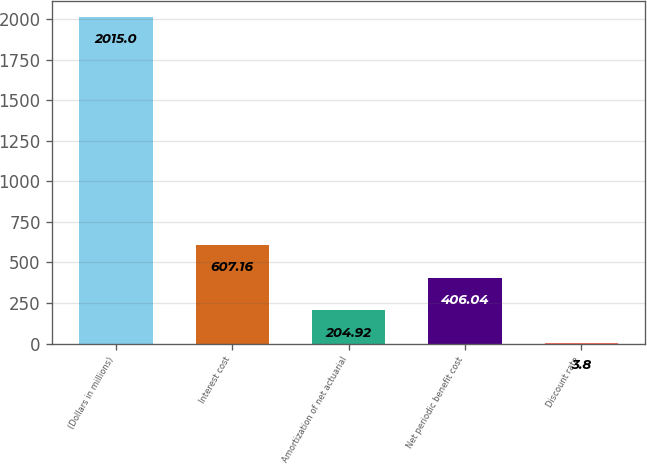Convert chart. <chart><loc_0><loc_0><loc_500><loc_500><bar_chart><fcel>(Dollars in millions)<fcel>Interest cost<fcel>Amortization of net actuarial<fcel>Net periodic benefit cost<fcel>Discount rate<nl><fcel>2015<fcel>607.16<fcel>204.92<fcel>406.04<fcel>3.8<nl></chart> 